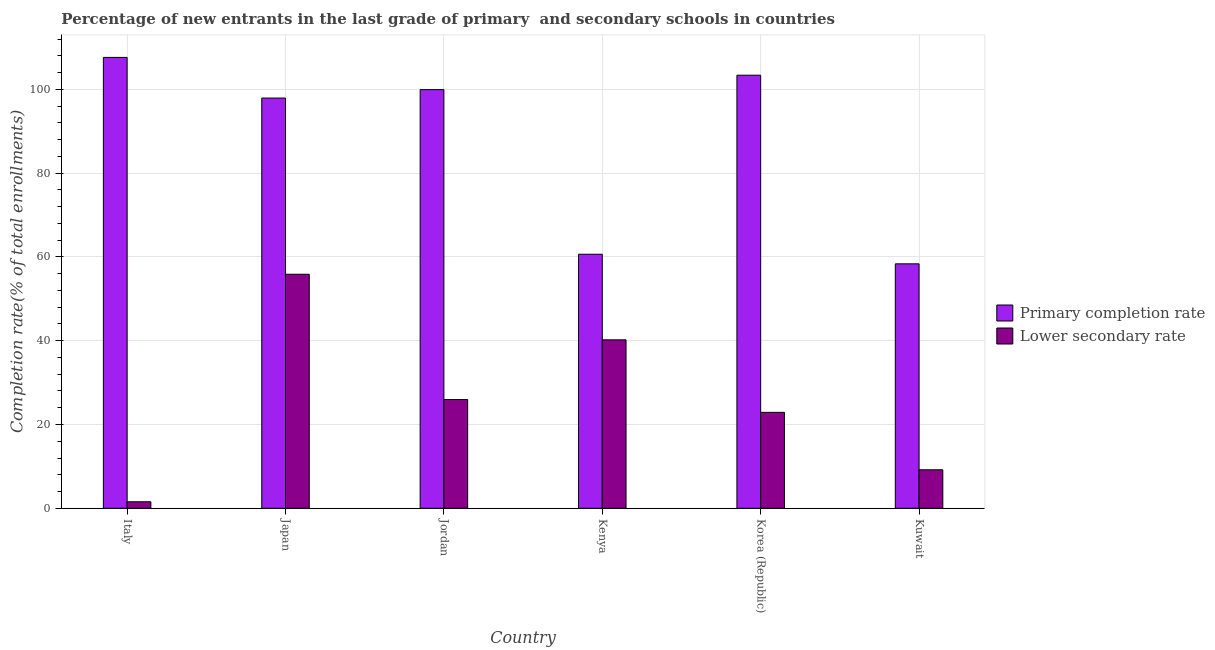How many different coloured bars are there?
Provide a succinct answer. 2. Are the number of bars on each tick of the X-axis equal?
Provide a short and direct response. Yes. How many bars are there on the 2nd tick from the right?
Offer a terse response. 2. What is the completion rate in primary schools in Korea (Republic)?
Provide a succinct answer. 103.38. Across all countries, what is the maximum completion rate in primary schools?
Your response must be concise. 107.62. Across all countries, what is the minimum completion rate in secondary schools?
Your answer should be compact. 1.55. In which country was the completion rate in secondary schools minimum?
Keep it short and to the point. Italy. What is the total completion rate in primary schools in the graph?
Keep it short and to the point. 527.86. What is the difference between the completion rate in primary schools in Italy and that in Kuwait?
Ensure brevity in your answer.  49.27. What is the difference between the completion rate in primary schools in Kenya and the completion rate in secondary schools in Japan?
Provide a short and direct response. 4.78. What is the average completion rate in secondary schools per country?
Your answer should be compact. 25.94. What is the difference between the completion rate in secondary schools and completion rate in primary schools in Kenya?
Provide a short and direct response. -20.43. What is the ratio of the completion rate in primary schools in Italy to that in Kuwait?
Provide a short and direct response. 1.84. Is the completion rate in secondary schools in Jordan less than that in Kenya?
Give a very brief answer. Yes. Is the difference between the completion rate in secondary schools in Japan and Kuwait greater than the difference between the completion rate in primary schools in Japan and Kuwait?
Ensure brevity in your answer.  Yes. What is the difference between the highest and the second highest completion rate in primary schools?
Ensure brevity in your answer.  4.25. What is the difference between the highest and the lowest completion rate in primary schools?
Ensure brevity in your answer.  49.27. In how many countries, is the completion rate in secondary schools greater than the average completion rate in secondary schools taken over all countries?
Provide a succinct answer. 3. Is the sum of the completion rate in primary schools in Jordan and Kuwait greater than the maximum completion rate in secondary schools across all countries?
Your answer should be compact. Yes. What does the 2nd bar from the left in Japan represents?
Your answer should be very brief. Lower secondary rate. What does the 2nd bar from the right in Japan represents?
Provide a short and direct response. Primary completion rate. How many bars are there?
Your answer should be very brief. 12. How many countries are there in the graph?
Give a very brief answer. 6. What is the difference between two consecutive major ticks on the Y-axis?
Your answer should be very brief. 20. Are the values on the major ticks of Y-axis written in scientific E-notation?
Ensure brevity in your answer.  No. Does the graph contain any zero values?
Provide a short and direct response. No. How are the legend labels stacked?
Your answer should be very brief. Vertical. What is the title of the graph?
Your response must be concise. Percentage of new entrants in the last grade of primary  and secondary schools in countries. Does "Private credit bureau" appear as one of the legend labels in the graph?
Provide a short and direct response. No. What is the label or title of the X-axis?
Provide a short and direct response. Country. What is the label or title of the Y-axis?
Your answer should be very brief. Completion rate(% of total enrollments). What is the Completion rate(% of total enrollments) of Primary completion rate in Italy?
Ensure brevity in your answer.  107.62. What is the Completion rate(% of total enrollments) of Lower secondary rate in Italy?
Provide a short and direct response. 1.55. What is the Completion rate(% of total enrollments) in Primary completion rate in Japan?
Your answer should be very brief. 97.92. What is the Completion rate(% of total enrollments) of Lower secondary rate in Japan?
Keep it short and to the point. 55.86. What is the Completion rate(% of total enrollments) of Primary completion rate in Jordan?
Make the answer very short. 99.94. What is the Completion rate(% of total enrollments) in Lower secondary rate in Jordan?
Provide a succinct answer. 25.95. What is the Completion rate(% of total enrollments) of Primary completion rate in Kenya?
Give a very brief answer. 60.64. What is the Completion rate(% of total enrollments) of Lower secondary rate in Kenya?
Provide a succinct answer. 40.21. What is the Completion rate(% of total enrollments) of Primary completion rate in Korea (Republic)?
Provide a short and direct response. 103.38. What is the Completion rate(% of total enrollments) of Lower secondary rate in Korea (Republic)?
Keep it short and to the point. 22.9. What is the Completion rate(% of total enrollments) of Primary completion rate in Kuwait?
Offer a very short reply. 58.35. What is the Completion rate(% of total enrollments) in Lower secondary rate in Kuwait?
Your answer should be very brief. 9.19. Across all countries, what is the maximum Completion rate(% of total enrollments) in Primary completion rate?
Ensure brevity in your answer.  107.62. Across all countries, what is the maximum Completion rate(% of total enrollments) of Lower secondary rate?
Ensure brevity in your answer.  55.86. Across all countries, what is the minimum Completion rate(% of total enrollments) in Primary completion rate?
Give a very brief answer. 58.35. Across all countries, what is the minimum Completion rate(% of total enrollments) in Lower secondary rate?
Your answer should be compact. 1.55. What is the total Completion rate(% of total enrollments) in Primary completion rate in the graph?
Make the answer very short. 527.86. What is the total Completion rate(% of total enrollments) of Lower secondary rate in the graph?
Provide a succinct answer. 155.66. What is the difference between the Completion rate(% of total enrollments) of Primary completion rate in Italy and that in Japan?
Provide a short and direct response. 9.7. What is the difference between the Completion rate(% of total enrollments) of Lower secondary rate in Italy and that in Japan?
Your answer should be very brief. -54.31. What is the difference between the Completion rate(% of total enrollments) of Primary completion rate in Italy and that in Jordan?
Offer a terse response. 7.69. What is the difference between the Completion rate(% of total enrollments) of Lower secondary rate in Italy and that in Jordan?
Offer a terse response. -24.41. What is the difference between the Completion rate(% of total enrollments) in Primary completion rate in Italy and that in Kenya?
Ensure brevity in your answer.  46.98. What is the difference between the Completion rate(% of total enrollments) of Lower secondary rate in Italy and that in Kenya?
Offer a very short reply. -38.66. What is the difference between the Completion rate(% of total enrollments) in Primary completion rate in Italy and that in Korea (Republic)?
Your answer should be very brief. 4.25. What is the difference between the Completion rate(% of total enrollments) of Lower secondary rate in Italy and that in Korea (Republic)?
Ensure brevity in your answer.  -21.35. What is the difference between the Completion rate(% of total enrollments) in Primary completion rate in Italy and that in Kuwait?
Keep it short and to the point. 49.27. What is the difference between the Completion rate(% of total enrollments) in Lower secondary rate in Italy and that in Kuwait?
Offer a terse response. -7.64. What is the difference between the Completion rate(% of total enrollments) of Primary completion rate in Japan and that in Jordan?
Ensure brevity in your answer.  -2.01. What is the difference between the Completion rate(% of total enrollments) in Lower secondary rate in Japan and that in Jordan?
Keep it short and to the point. 29.91. What is the difference between the Completion rate(% of total enrollments) of Primary completion rate in Japan and that in Kenya?
Offer a terse response. 37.28. What is the difference between the Completion rate(% of total enrollments) in Lower secondary rate in Japan and that in Kenya?
Offer a very short reply. 15.65. What is the difference between the Completion rate(% of total enrollments) of Primary completion rate in Japan and that in Korea (Republic)?
Keep it short and to the point. -5.46. What is the difference between the Completion rate(% of total enrollments) of Lower secondary rate in Japan and that in Korea (Republic)?
Offer a terse response. 32.96. What is the difference between the Completion rate(% of total enrollments) of Primary completion rate in Japan and that in Kuwait?
Offer a very short reply. 39.57. What is the difference between the Completion rate(% of total enrollments) of Lower secondary rate in Japan and that in Kuwait?
Offer a terse response. 46.68. What is the difference between the Completion rate(% of total enrollments) in Primary completion rate in Jordan and that in Kenya?
Provide a short and direct response. 39.3. What is the difference between the Completion rate(% of total enrollments) of Lower secondary rate in Jordan and that in Kenya?
Provide a succinct answer. -14.25. What is the difference between the Completion rate(% of total enrollments) in Primary completion rate in Jordan and that in Korea (Republic)?
Your answer should be very brief. -3.44. What is the difference between the Completion rate(% of total enrollments) of Lower secondary rate in Jordan and that in Korea (Republic)?
Provide a succinct answer. 3.06. What is the difference between the Completion rate(% of total enrollments) of Primary completion rate in Jordan and that in Kuwait?
Your response must be concise. 41.59. What is the difference between the Completion rate(% of total enrollments) of Lower secondary rate in Jordan and that in Kuwait?
Keep it short and to the point. 16.77. What is the difference between the Completion rate(% of total enrollments) of Primary completion rate in Kenya and that in Korea (Republic)?
Provide a succinct answer. -42.74. What is the difference between the Completion rate(% of total enrollments) of Lower secondary rate in Kenya and that in Korea (Republic)?
Offer a very short reply. 17.31. What is the difference between the Completion rate(% of total enrollments) in Primary completion rate in Kenya and that in Kuwait?
Provide a succinct answer. 2.29. What is the difference between the Completion rate(% of total enrollments) of Lower secondary rate in Kenya and that in Kuwait?
Your response must be concise. 31.02. What is the difference between the Completion rate(% of total enrollments) of Primary completion rate in Korea (Republic) and that in Kuwait?
Give a very brief answer. 45.03. What is the difference between the Completion rate(% of total enrollments) in Lower secondary rate in Korea (Republic) and that in Kuwait?
Keep it short and to the point. 13.71. What is the difference between the Completion rate(% of total enrollments) in Primary completion rate in Italy and the Completion rate(% of total enrollments) in Lower secondary rate in Japan?
Your answer should be very brief. 51.76. What is the difference between the Completion rate(% of total enrollments) of Primary completion rate in Italy and the Completion rate(% of total enrollments) of Lower secondary rate in Jordan?
Your answer should be compact. 81.67. What is the difference between the Completion rate(% of total enrollments) of Primary completion rate in Italy and the Completion rate(% of total enrollments) of Lower secondary rate in Kenya?
Give a very brief answer. 67.42. What is the difference between the Completion rate(% of total enrollments) in Primary completion rate in Italy and the Completion rate(% of total enrollments) in Lower secondary rate in Korea (Republic)?
Provide a succinct answer. 84.73. What is the difference between the Completion rate(% of total enrollments) in Primary completion rate in Italy and the Completion rate(% of total enrollments) in Lower secondary rate in Kuwait?
Your response must be concise. 98.44. What is the difference between the Completion rate(% of total enrollments) of Primary completion rate in Japan and the Completion rate(% of total enrollments) of Lower secondary rate in Jordan?
Give a very brief answer. 71.97. What is the difference between the Completion rate(% of total enrollments) in Primary completion rate in Japan and the Completion rate(% of total enrollments) in Lower secondary rate in Kenya?
Provide a succinct answer. 57.72. What is the difference between the Completion rate(% of total enrollments) of Primary completion rate in Japan and the Completion rate(% of total enrollments) of Lower secondary rate in Korea (Republic)?
Offer a terse response. 75.03. What is the difference between the Completion rate(% of total enrollments) in Primary completion rate in Japan and the Completion rate(% of total enrollments) in Lower secondary rate in Kuwait?
Offer a very short reply. 88.74. What is the difference between the Completion rate(% of total enrollments) in Primary completion rate in Jordan and the Completion rate(% of total enrollments) in Lower secondary rate in Kenya?
Offer a terse response. 59.73. What is the difference between the Completion rate(% of total enrollments) of Primary completion rate in Jordan and the Completion rate(% of total enrollments) of Lower secondary rate in Korea (Republic)?
Offer a terse response. 77.04. What is the difference between the Completion rate(% of total enrollments) of Primary completion rate in Jordan and the Completion rate(% of total enrollments) of Lower secondary rate in Kuwait?
Make the answer very short. 90.75. What is the difference between the Completion rate(% of total enrollments) of Primary completion rate in Kenya and the Completion rate(% of total enrollments) of Lower secondary rate in Korea (Republic)?
Give a very brief answer. 37.74. What is the difference between the Completion rate(% of total enrollments) of Primary completion rate in Kenya and the Completion rate(% of total enrollments) of Lower secondary rate in Kuwait?
Provide a succinct answer. 51.45. What is the difference between the Completion rate(% of total enrollments) of Primary completion rate in Korea (Republic) and the Completion rate(% of total enrollments) of Lower secondary rate in Kuwait?
Ensure brevity in your answer.  94.19. What is the average Completion rate(% of total enrollments) in Primary completion rate per country?
Keep it short and to the point. 87.98. What is the average Completion rate(% of total enrollments) of Lower secondary rate per country?
Your answer should be very brief. 25.94. What is the difference between the Completion rate(% of total enrollments) of Primary completion rate and Completion rate(% of total enrollments) of Lower secondary rate in Italy?
Give a very brief answer. 106.08. What is the difference between the Completion rate(% of total enrollments) of Primary completion rate and Completion rate(% of total enrollments) of Lower secondary rate in Japan?
Provide a short and direct response. 42.06. What is the difference between the Completion rate(% of total enrollments) of Primary completion rate and Completion rate(% of total enrollments) of Lower secondary rate in Jordan?
Keep it short and to the point. 73.98. What is the difference between the Completion rate(% of total enrollments) in Primary completion rate and Completion rate(% of total enrollments) in Lower secondary rate in Kenya?
Offer a very short reply. 20.43. What is the difference between the Completion rate(% of total enrollments) of Primary completion rate and Completion rate(% of total enrollments) of Lower secondary rate in Korea (Republic)?
Your answer should be compact. 80.48. What is the difference between the Completion rate(% of total enrollments) in Primary completion rate and Completion rate(% of total enrollments) in Lower secondary rate in Kuwait?
Ensure brevity in your answer.  49.17. What is the ratio of the Completion rate(% of total enrollments) of Primary completion rate in Italy to that in Japan?
Offer a terse response. 1.1. What is the ratio of the Completion rate(% of total enrollments) of Lower secondary rate in Italy to that in Japan?
Your response must be concise. 0.03. What is the ratio of the Completion rate(% of total enrollments) of Lower secondary rate in Italy to that in Jordan?
Offer a very short reply. 0.06. What is the ratio of the Completion rate(% of total enrollments) of Primary completion rate in Italy to that in Kenya?
Offer a terse response. 1.77. What is the ratio of the Completion rate(% of total enrollments) in Lower secondary rate in Italy to that in Kenya?
Provide a succinct answer. 0.04. What is the ratio of the Completion rate(% of total enrollments) of Primary completion rate in Italy to that in Korea (Republic)?
Give a very brief answer. 1.04. What is the ratio of the Completion rate(% of total enrollments) of Lower secondary rate in Italy to that in Korea (Republic)?
Provide a succinct answer. 0.07. What is the ratio of the Completion rate(% of total enrollments) of Primary completion rate in Italy to that in Kuwait?
Your response must be concise. 1.84. What is the ratio of the Completion rate(% of total enrollments) in Lower secondary rate in Italy to that in Kuwait?
Offer a terse response. 0.17. What is the ratio of the Completion rate(% of total enrollments) of Primary completion rate in Japan to that in Jordan?
Keep it short and to the point. 0.98. What is the ratio of the Completion rate(% of total enrollments) of Lower secondary rate in Japan to that in Jordan?
Make the answer very short. 2.15. What is the ratio of the Completion rate(% of total enrollments) of Primary completion rate in Japan to that in Kenya?
Keep it short and to the point. 1.61. What is the ratio of the Completion rate(% of total enrollments) in Lower secondary rate in Japan to that in Kenya?
Your answer should be very brief. 1.39. What is the ratio of the Completion rate(% of total enrollments) in Primary completion rate in Japan to that in Korea (Republic)?
Give a very brief answer. 0.95. What is the ratio of the Completion rate(% of total enrollments) of Lower secondary rate in Japan to that in Korea (Republic)?
Your response must be concise. 2.44. What is the ratio of the Completion rate(% of total enrollments) in Primary completion rate in Japan to that in Kuwait?
Keep it short and to the point. 1.68. What is the ratio of the Completion rate(% of total enrollments) of Lower secondary rate in Japan to that in Kuwait?
Offer a terse response. 6.08. What is the ratio of the Completion rate(% of total enrollments) in Primary completion rate in Jordan to that in Kenya?
Provide a succinct answer. 1.65. What is the ratio of the Completion rate(% of total enrollments) in Lower secondary rate in Jordan to that in Kenya?
Give a very brief answer. 0.65. What is the ratio of the Completion rate(% of total enrollments) of Primary completion rate in Jordan to that in Korea (Republic)?
Your answer should be very brief. 0.97. What is the ratio of the Completion rate(% of total enrollments) in Lower secondary rate in Jordan to that in Korea (Republic)?
Your response must be concise. 1.13. What is the ratio of the Completion rate(% of total enrollments) of Primary completion rate in Jordan to that in Kuwait?
Offer a very short reply. 1.71. What is the ratio of the Completion rate(% of total enrollments) in Lower secondary rate in Jordan to that in Kuwait?
Provide a succinct answer. 2.83. What is the ratio of the Completion rate(% of total enrollments) in Primary completion rate in Kenya to that in Korea (Republic)?
Make the answer very short. 0.59. What is the ratio of the Completion rate(% of total enrollments) of Lower secondary rate in Kenya to that in Korea (Republic)?
Provide a succinct answer. 1.76. What is the ratio of the Completion rate(% of total enrollments) of Primary completion rate in Kenya to that in Kuwait?
Give a very brief answer. 1.04. What is the ratio of the Completion rate(% of total enrollments) of Lower secondary rate in Kenya to that in Kuwait?
Offer a terse response. 4.38. What is the ratio of the Completion rate(% of total enrollments) of Primary completion rate in Korea (Republic) to that in Kuwait?
Provide a succinct answer. 1.77. What is the ratio of the Completion rate(% of total enrollments) in Lower secondary rate in Korea (Republic) to that in Kuwait?
Make the answer very short. 2.49. What is the difference between the highest and the second highest Completion rate(% of total enrollments) of Primary completion rate?
Ensure brevity in your answer.  4.25. What is the difference between the highest and the second highest Completion rate(% of total enrollments) in Lower secondary rate?
Your answer should be compact. 15.65. What is the difference between the highest and the lowest Completion rate(% of total enrollments) in Primary completion rate?
Your response must be concise. 49.27. What is the difference between the highest and the lowest Completion rate(% of total enrollments) in Lower secondary rate?
Provide a short and direct response. 54.31. 